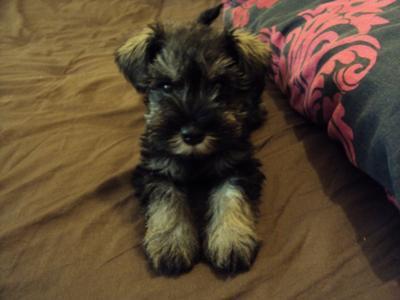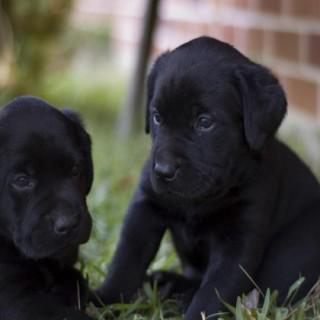The first image is the image on the left, the second image is the image on the right. For the images displayed, is the sentence "There are at least three dogs in the right image." factually correct? Answer yes or no. No. The first image is the image on the left, the second image is the image on the right. Analyze the images presented: Is the assertion "All dogs are schnauzer puppies, and at least some dogs have white eyebrows." valid? Answer yes or no. No. 